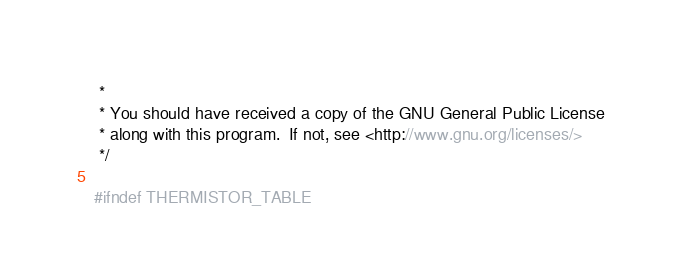Convert code to text. <code><loc_0><loc_0><loc_500><loc_500><_C++_> *
 * You should have received a copy of the GNU General Public License
 * along with this program.  If not, see <http://www.gnu.org/licenses/>
 */

#ifndef THERMISTOR_TABLE</code> 